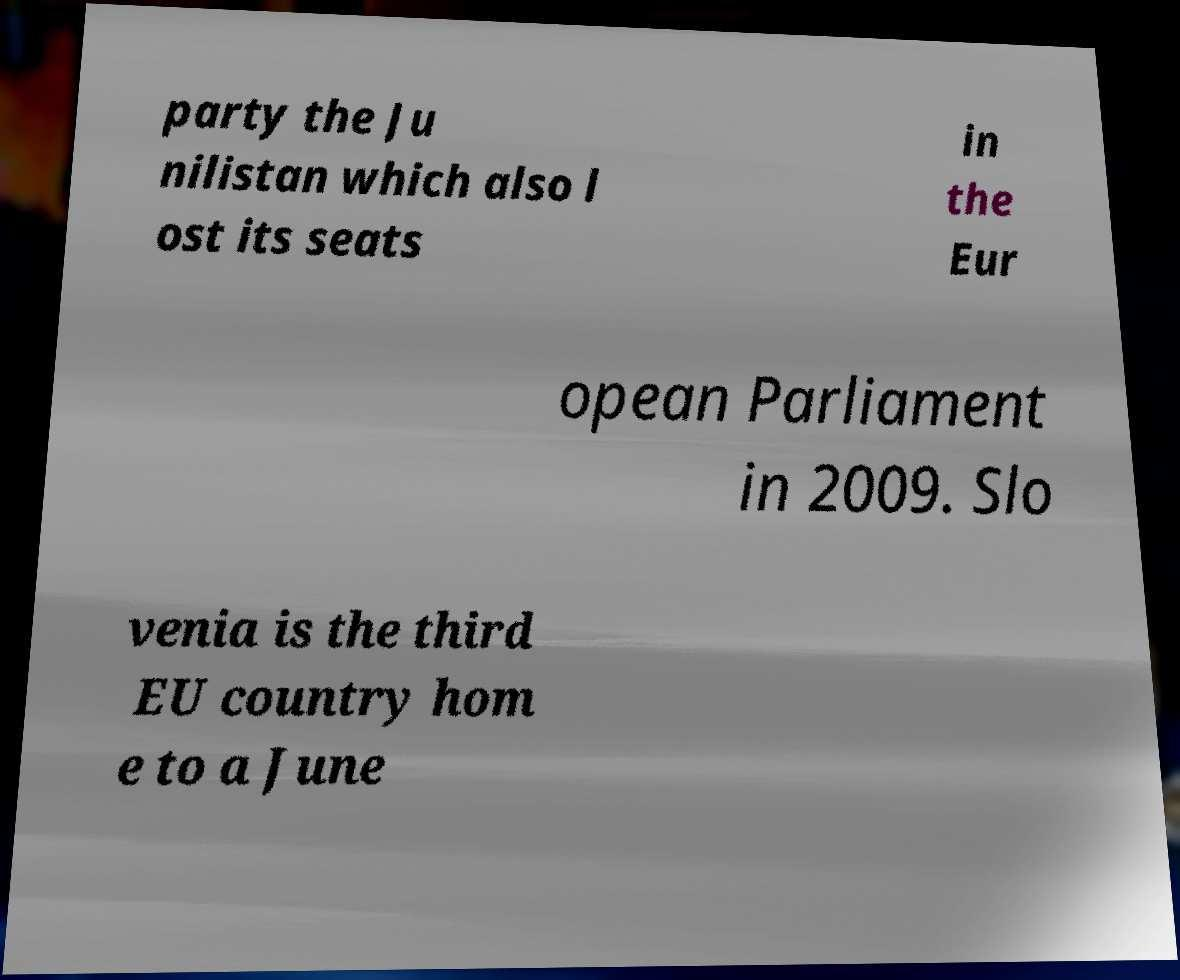Can you accurately transcribe the text from the provided image for me? party the Ju nilistan which also l ost its seats in the Eur opean Parliament in 2009. Slo venia is the third EU country hom e to a June 